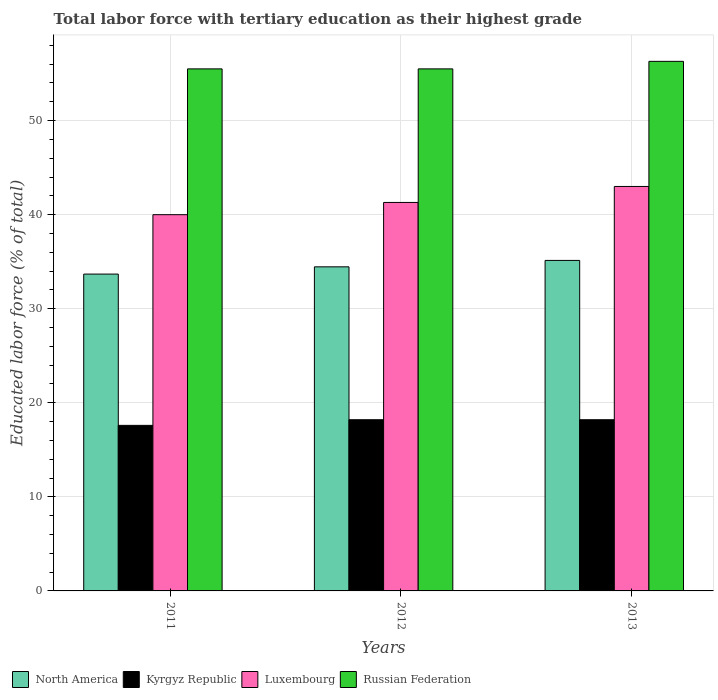How many different coloured bars are there?
Provide a short and direct response. 4. How many groups of bars are there?
Offer a very short reply. 3. Are the number of bars on each tick of the X-axis equal?
Provide a short and direct response. Yes. How many bars are there on the 3rd tick from the right?
Keep it short and to the point. 4. Across all years, what is the maximum percentage of male labor force with tertiary education in Kyrgyz Republic?
Provide a short and direct response. 18.2. Across all years, what is the minimum percentage of male labor force with tertiary education in Russian Federation?
Keep it short and to the point. 55.5. In which year was the percentage of male labor force with tertiary education in North America maximum?
Keep it short and to the point. 2013. What is the total percentage of male labor force with tertiary education in Russian Federation in the graph?
Your answer should be compact. 167.3. What is the difference between the percentage of male labor force with tertiary education in Kyrgyz Republic in 2011 and that in 2013?
Offer a very short reply. -0.6. What is the difference between the percentage of male labor force with tertiary education in Russian Federation in 2011 and the percentage of male labor force with tertiary education in Kyrgyz Republic in 2013?
Ensure brevity in your answer.  37.3. What is the average percentage of male labor force with tertiary education in Russian Federation per year?
Offer a terse response. 55.77. In the year 2011, what is the difference between the percentage of male labor force with tertiary education in North America and percentage of male labor force with tertiary education in Russian Federation?
Make the answer very short. -21.82. In how many years, is the percentage of male labor force with tertiary education in Russian Federation greater than 24 %?
Your answer should be very brief. 3. What is the ratio of the percentage of male labor force with tertiary education in Luxembourg in 2011 to that in 2012?
Your answer should be very brief. 0.97. Is the percentage of male labor force with tertiary education in North America in 2011 less than that in 2012?
Provide a succinct answer. Yes. Is the difference between the percentage of male labor force with tertiary education in North America in 2011 and 2012 greater than the difference between the percentage of male labor force with tertiary education in Russian Federation in 2011 and 2012?
Give a very brief answer. No. What is the difference between the highest and the second highest percentage of male labor force with tertiary education in Luxembourg?
Make the answer very short. 1.7. Is it the case that in every year, the sum of the percentage of male labor force with tertiary education in Russian Federation and percentage of male labor force with tertiary education in Luxembourg is greater than the sum of percentage of male labor force with tertiary education in Kyrgyz Republic and percentage of male labor force with tertiary education in North America?
Make the answer very short. No. What does the 1st bar from the left in 2011 represents?
Your response must be concise. North America. What does the 1st bar from the right in 2012 represents?
Keep it short and to the point. Russian Federation. Does the graph contain grids?
Ensure brevity in your answer.  Yes. Where does the legend appear in the graph?
Make the answer very short. Bottom left. How many legend labels are there?
Make the answer very short. 4. What is the title of the graph?
Offer a very short reply. Total labor force with tertiary education as their highest grade. Does "Tuvalu" appear as one of the legend labels in the graph?
Keep it short and to the point. No. What is the label or title of the Y-axis?
Offer a terse response. Educated labor force (% of total). What is the Educated labor force (% of total) in North America in 2011?
Offer a terse response. 33.68. What is the Educated labor force (% of total) of Kyrgyz Republic in 2011?
Your response must be concise. 17.6. What is the Educated labor force (% of total) of Luxembourg in 2011?
Keep it short and to the point. 40. What is the Educated labor force (% of total) of Russian Federation in 2011?
Keep it short and to the point. 55.5. What is the Educated labor force (% of total) of North America in 2012?
Your answer should be compact. 34.45. What is the Educated labor force (% of total) of Kyrgyz Republic in 2012?
Your answer should be very brief. 18.2. What is the Educated labor force (% of total) of Luxembourg in 2012?
Offer a terse response. 41.3. What is the Educated labor force (% of total) of Russian Federation in 2012?
Offer a very short reply. 55.5. What is the Educated labor force (% of total) of North America in 2013?
Offer a very short reply. 35.14. What is the Educated labor force (% of total) of Kyrgyz Republic in 2013?
Provide a succinct answer. 18.2. What is the Educated labor force (% of total) in Russian Federation in 2013?
Give a very brief answer. 56.3. Across all years, what is the maximum Educated labor force (% of total) in North America?
Provide a succinct answer. 35.14. Across all years, what is the maximum Educated labor force (% of total) in Kyrgyz Republic?
Offer a very short reply. 18.2. Across all years, what is the maximum Educated labor force (% of total) in Russian Federation?
Give a very brief answer. 56.3. Across all years, what is the minimum Educated labor force (% of total) in North America?
Offer a terse response. 33.68. Across all years, what is the minimum Educated labor force (% of total) of Kyrgyz Republic?
Your response must be concise. 17.6. Across all years, what is the minimum Educated labor force (% of total) in Luxembourg?
Keep it short and to the point. 40. Across all years, what is the minimum Educated labor force (% of total) of Russian Federation?
Provide a short and direct response. 55.5. What is the total Educated labor force (% of total) of North America in the graph?
Provide a succinct answer. 103.28. What is the total Educated labor force (% of total) in Kyrgyz Republic in the graph?
Your answer should be compact. 54. What is the total Educated labor force (% of total) in Luxembourg in the graph?
Provide a succinct answer. 124.3. What is the total Educated labor force (% of total) of Russian Federation in the graph?
Your answer should be compact. 167.3. What is the difference between the Educated labor force (% of total) in North America in 2011 and that in 2012?
Ensure brevity in your answer.  -0.77. What is the difference between the Educated labor force (% of total) of Kyrgyz Republic in 2011 and that in 2012?
Provide a succinct answer. -0.6. What is the difference between the Educated labor force (% of total) of Russian Federation in 2011 and that in 2012?
Keep it short and to the point. 0. What is the difference between the Educated labor force (% of total) of North America in 2011 and that in 2013?
Provide a short and direct response. -1.45. What is the difference between the Educated labor force (% of total) in Russian Federation in 2011 and that in 2013?
Make the answer very short. -0.8. What is the difference between the Educated labor force (% of total) of North America in 2012 and that in 2013?
Give a very brief answer. -0.68. What is the difference between the Educated labor force (% of total) of Kyrgyz Republic in 2012 and that in 2013?
Provide a succinct answer. 0. What is the difference between the Educated labor force (% of total) in Luxembourg in 2012 and that in 2013?
Give a very brief answer. -1.7. What is the difference between the Educated labor force (% of total) of Russian Federation in 2012 and that in 2013?
Keep it short and to the point. -0.8. What is the difference between the Educated labor force (% of total) in North America in 2011 and the Educated labor force (% of total) in Kyrgyz Republic in 2012?
Your answer should be compact. 15.48. What is the difference between the Educated labor force (% of total) in North America in 2011 and the Educated labor force (% of total) in Luxembourg in 2012?
Offer a very short reply. -7.62. What is the difference between the Educated labor force (% of total) in North America in 2011 and the Educated labor force (% of total) in Russian Federation in 2012?
Give a very brief answer. -21.82. What is the difference between the Educated labor force (% of total) of Kyrgyz Republic in 2011 and the Educated labor force (% of total) of Luxembourg in 2012?
Give a very brief answer. -23.7. What is the difference between the Educated labor force (% of total) of Kyrgyz Republic in 2011 and the Educated labor force (% of total) of Russian Federation in 2012?
Ensure brevity in your answer.  -37.9. What is the difference between the Educated labor force (% of total) of Luxembourg in 2011 and the Educated labor force (% of total) of Russian Federation in 2012?
Offer a very short reply. -15.5. What is the difference between the Educated labor force (% of total) of North America in 2011 and the Educated labor force (% of total) of Kyrgyz Republic in 2013?
Ensure brevity in your answer.  15.48. What is the difference between the Educated labor force (% of total) in North America in 2011 and the Educated labor force (% of total) in Luxembourg in 2013?
Give a very brief answer. -9.32. What is the difference between the Educated labor force (% of total) of North America in 2011 and the Educated labor force (% of total) of Russian Federation in 2013?
Make the answer very short. -22.62. What is the difference between the Educated labor force (% of total) of Kyrgyz Republic in 2011 and the Educated labor force (% of total) of Luxembourg in 2013?
Your answer should be very brief. -25.4. What is the difference between the Educated labor force (% of total) in Kyrgyz Republic in 2011 and the Educated labor force (% of total) in Russian Federation in 2013?
Make the answer very short. -38.7. What is the difference between the Educated labor force (% of total) of Luxembourg in 2011 and the Educated labor force (% of total) of Russian Federation in 2013?
Your response must be concise. -16.3. What is the difference between the Educated labor force (% of total) of North America in 2012 and the Educated labor force (% of total) of Kyrgyz Republic in 2013?
Make the answer very short. 16.25. What is the difference between the Educated labor force (% of total) of North America in 2012 and the Educated labor force (% of total) of Luxembourg in 2013?
Your answer should be very brief. -8.54. What is the difference between the Educated labor force (% of total) of North America in 2012 and the Educated labor force (% of total) of Russian Federation in 2013?
Make the answer very short. -21.84. What is the difference between the Educated labor force (% of total) in Kyrgyz Republic in 2012 and the Educated labor force (% of total) in Luxembourg in 2013?
Make the answer very short. -24.8. What is the difference between the Educated labor force (% of total) in Kyrgyz Republic in 2012 and the Educated labor force (% of total) in Russian Federation in 2013?
Provide a short and direct response. -38.1. What is the difference between the Educated labor force (% of total) of Luxembourg in 2012 and the Educated labor force (% of total) of Russian Federation in 2013?
Provide a short and direct response. -15. What is the average Educated labor force (% of total) of North America per year?
Keep it short and to the point. 34.43. What is the average Educated labor force (% of total) of Kyrgyz Republic per year?
Your answer should be compact. 18. What is the average Educated labor force (% of total) in Luxembourg per year?
Give a very brief answer. 41.43. What is the average Educated labor force (% of total) of Russian Federation per year?
Provide a short and direct response. 55.77. In the year 2011, what is the difference between the Educated labor force (% of total) of North America and Educated labor force (% of total) of Kyrgyz Republic?
Ensure brevity in your answer.  16.08. In the year 2011, what is the difference between the Educated labor force (% of total) in North America and Educated labor force (% of total) in Luxembourg?
Offer a terse response. -6.32. In the year 2011, what is the difference between the Educated labor force (% of total) in North America and Educated labor force (% of total) in Russian Federation?
Make the answer very short. -21.82. In the year 2011, what is the difference between the Educated labor force (% of total) of Kyrgyz Republic and Educated labor force (% of total) of Luxembourg?
Provide a succinct answer. -22.4. In the year 2011, what is the difference between the Educated labor force (% of total) of Kyrgyz Republic and Educated labor force (% of total) of Russian Federation?
Provide a short and direct response. -37.9. In the year 2011, what is the difference between the Educated labor force (% of total) in Luxembourg and Educated labor force (% of total) in Russian Federation?
Make the answer very short. -15.5. In the year 2012, what is the difference between the Educated labor force (% of total) of North America and Educated labor force (% of total) of Kyrgyz Republic?
Your answer should be very brief. 16.25. In the year 2012, what is the difference between the Educated labor force (% of total) of North America and Educated labor force (% of total) of Luxembourg?
Your answer should be compact. -6.84. In the year 2012, what is the difference between the Educated labor force (% of total) of North America and Educated labor force (% of total) of Russian Federation?
Your response must be concise. -21.05. In the year 2012, what is the difference between the Educated labor force (% of total) in Kyrgyz Republic and Educated labor force (% of total) in Luxembourg?
Ensure brevity in your answer.  -23.1. In the year 2012, what is the difference between the Educated labor force (% of total) of Kyrgyz Republic and Educated labor force (% of total) of Russian Federation?
Keep it short and to the point. -37.3. In the year 2012, what is the difference between the Educated labor force (% of total) in Luxembourg and Educated labor force (% of total) in Russian Federation?
Your answer should be compact. -14.2. In the year 2013, what is the difference between the Educated labor force (% of total) of North America and Educated labor force (% of total) of Kyrgyz Republic?
Your response must be concise. 16.94. In the year 2013, what is the difference between the Educated labor force (% of total) of North America and Educated labor force (% of total) of Luxembourg?
Keep it short and to the point. -7.86. In the year 2013, what is the difference between the Educated labor force (% of total) of North America and Educated labor force (% of total) of Russian Federation?
Provide a succinct answer. -21.16. In the year 2013, what is the difference between the Educated labor force (% of total) in Kyrgyz Republic and Educated labor force (% of total) in Luxembourg?
Ensure brevity in your answer.  -24.8. In the year 2013, what is the difference between the Educated labor force (% of total) in Kyrgyz Republic and Educated labor force (% of total) in Russian Federation?
Your answer should be compact. -38.1. What is the ratio of the Educated labor force (% of total) of North America in 2011 to that in 2012?
Make the answer very short. 0.98. What is the ratio of the Educated labor force (% of total) in Kyrgyz Republic in 2011 to that in 2012?
Offer a terse response. 0.97. What is the ratio of the Educated labor force (% of total) in Luxembourg in 2011 to that in 2012?
Provide a short and direct response. 0.97. What is the ratio of the Educated labor force (% of total) in Russian Federation in 2011 to that in 2012?
Keep it short and to the point. 1. What is the ratio of the Educated labor force (% of total) in North America in 2011 to that in 2013?
Give a very brief answer. 0.96. What is the ratio of the Educated labor force (% of total) in Luxembourg in 2011 to that in 2013?
Give a very brief answer. 0.93. What is the ratio of the Educated labor force (% of total) of Russian Federation in 2011 to that in 2013?
Your answer should be very brief. 0.99. What is the ratio of the Educated labor force (% of total) of North America in 2012 to that in 2013?
Provide a succinct answer. 0.98. What is the ratio of the Educated labor force (% of total) of Luxembourg in 2012 to that in 2013?
Ensure brevity in your answer.  0.96. What is the ratio of the Educated labor force (% of total) in Russian Federation in 2012 to that in 2013?
Make the answer very short. 0.99. What is the difference between the highest and the second highest Educated labor force (% of total) of North America?
Keep it short and to the point. 0.68. What is the difference between the highest and the second highest Educated labor force (% of total) of Russian Federation?
Provide a short and direct response. 0.8. What is the difference between the highest and the lowest Educated labor force (% of total) of North America?
Make the answer very short. 1.45. 